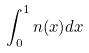<formula> <loc_0><loc_0><loc_500><loc_500>\int _ { 0 } ^ { 1 } n ( x ) d x</formula> 